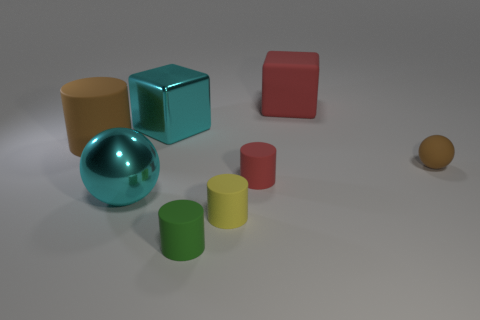Subtract all blue cylinders. Subtract all green blocks. How many cylinders are left? 4 Add 2 tiny red cylinders. How many objects exist? 10 Subtract all balls. How many objects are left? 6 Add 1 green rubber objects. How many green rubber objects exist? 2 Subtract 0 purple cylinders. How many objects are left? 8 Subtract all cyan shiny objects. Subtract all big shiny blocks. How many objects are left? 5 Add 8 tiny yellow matte cylinders. How many tiny yellow matte cylinders are left? 9 